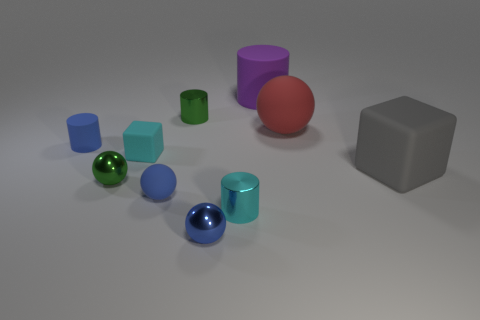Subtract 2 spheres. How many spheres are left? 2 Add 2 green shiny cylinders. How many green shiny cylinders are left? 3 Add 1 big gray rubber spheres. How many big gray rubber spheres exist? 1 Subtract all blue cylinders. How many cylinders are left? 3 Subtract all purple cylinders. How many cylinders are left? 3 Subtract 0 red cylinders. How many objects are left? 10 Subtract all spheres. How many objects are left? 6 Subtract all blue spheres. Subtract all blue cylinders. How many spheres are left? 2 Subtract all yellow cylinders. How many gray blocks are left? 1 Subtract all tiny brown metal blocks. Subtract all blue objects. How many objects are left? 7 